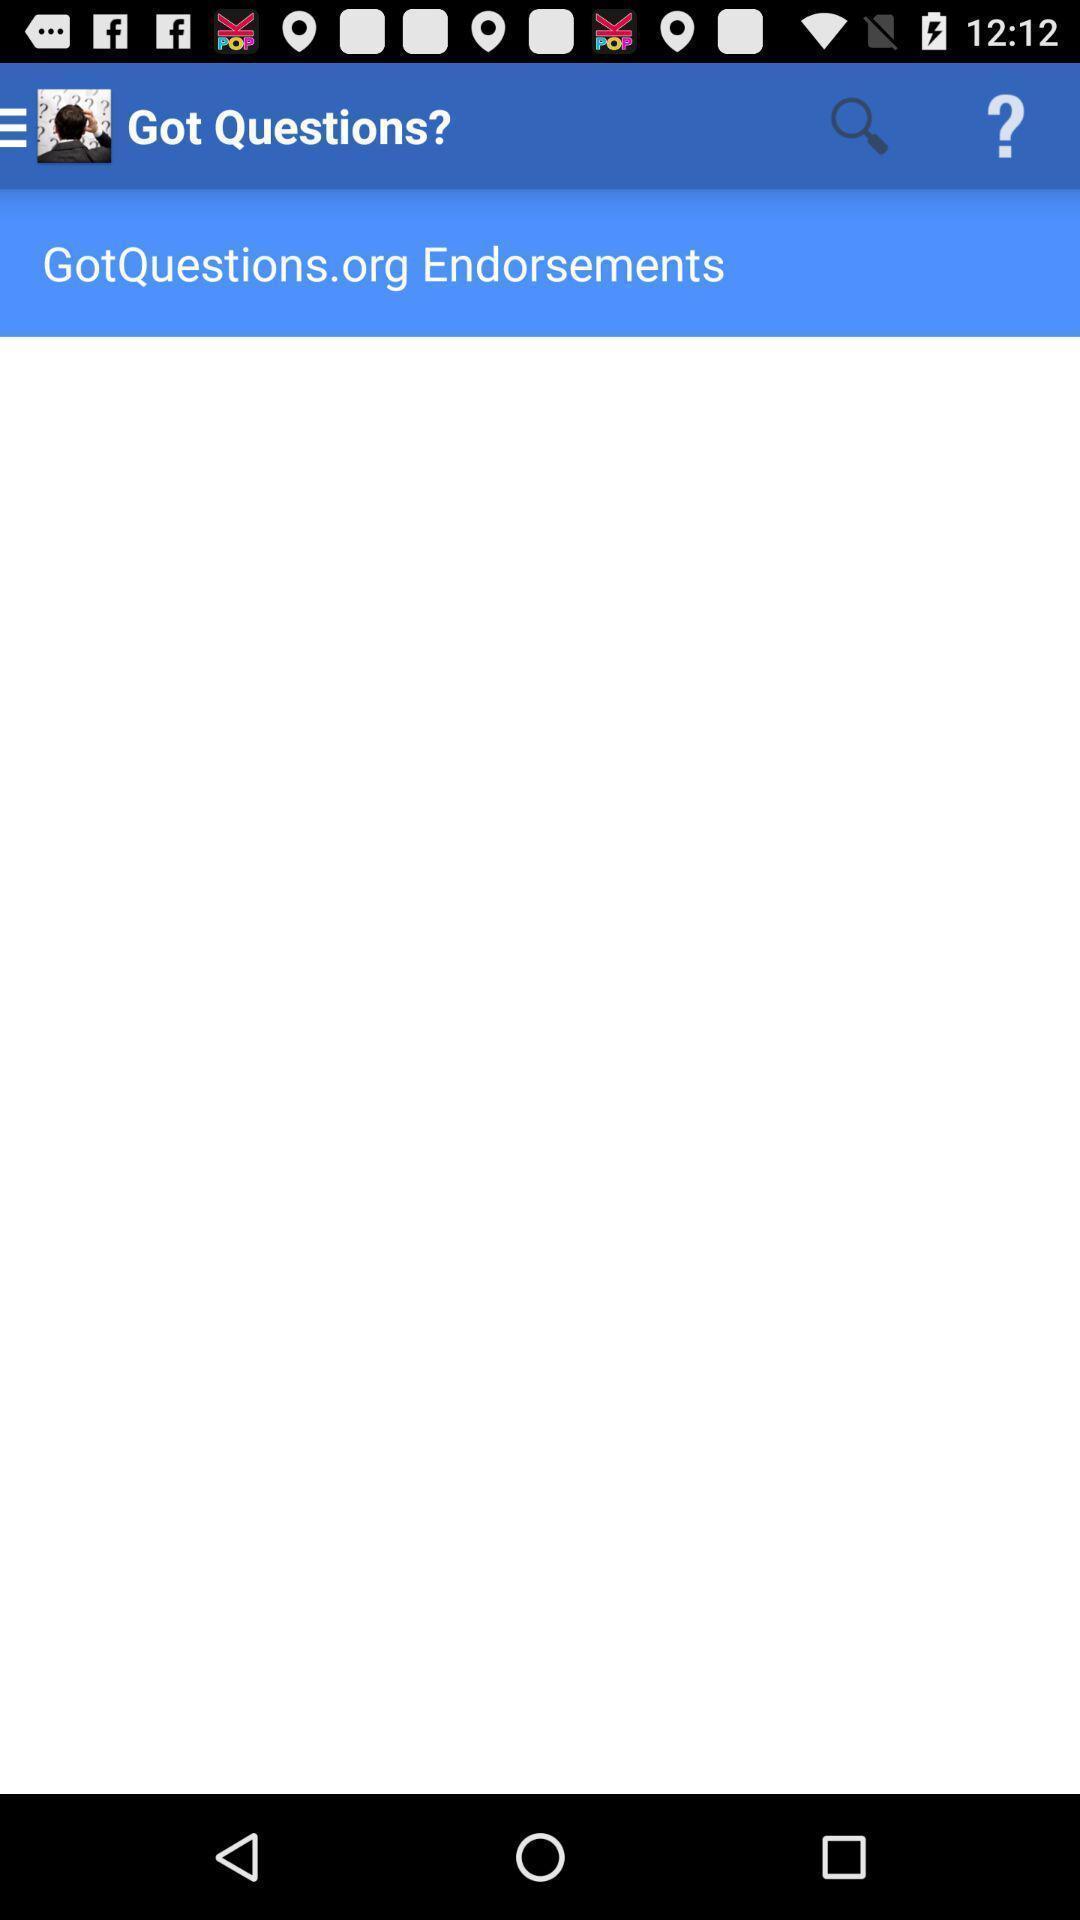What can you discern from this picture? Page shows got questions. 